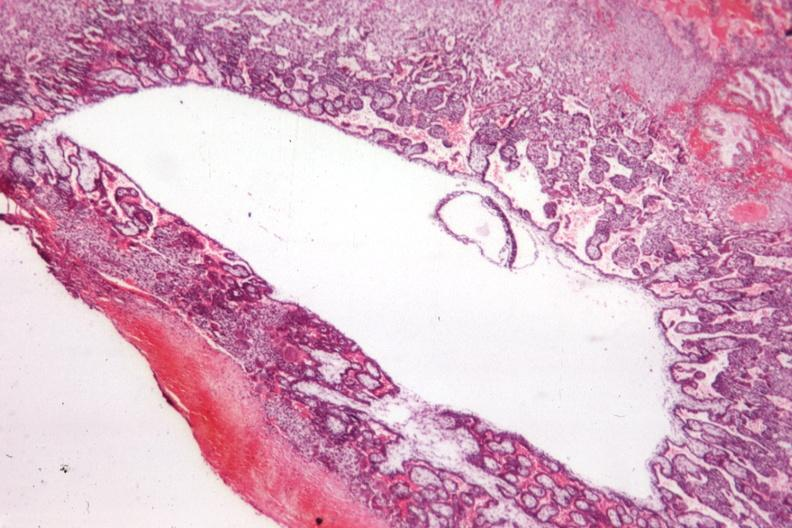where is this from?
Answer the question using a single word or phrase. Female reproductive system 